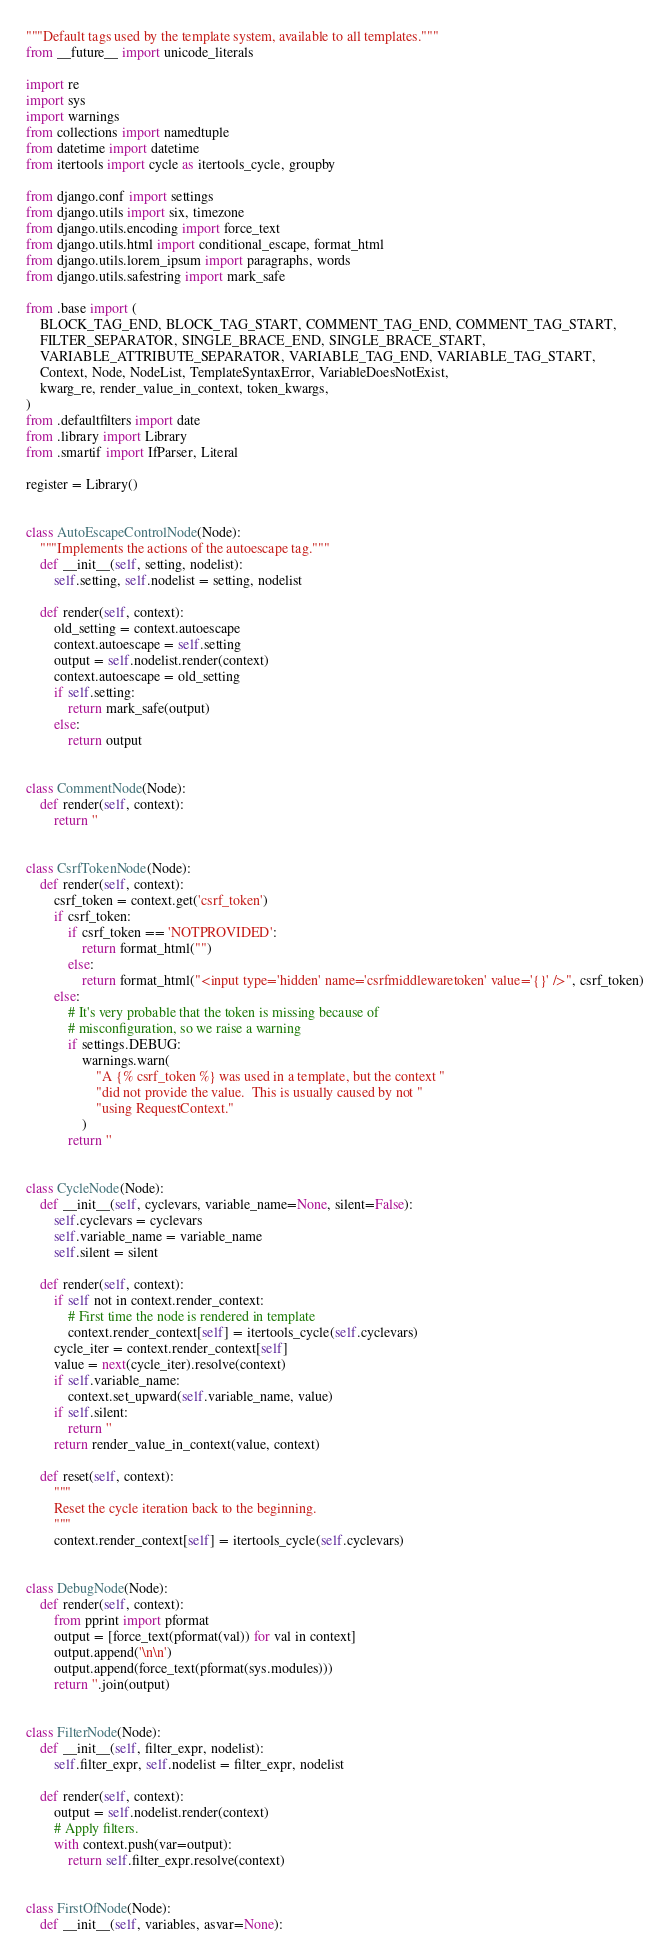Convert code to text. <code><loc_0><loc_0><loc_500><loc_500><_Python_>"""Default tags used by the template system, available to all templates."""
from __future__ import unicode_literals

import re
import sys
import warnings
from collections import namedtuple
from datetime import datetime
from itertools import cycle as itertools_cycle, groupby

from django.conf import settings
from django.utils import six, timezone
from django.utils.encoding import force_text
from django.utils.html import conditional_escape, format_html
from django.utils.lorem_ipsum import paragraphs, words
from django.utils.safestring import mark_safe

from .base import (
    BLOCK_TAG_END, BLOCK_TAG_START, COMMENT_TAG_END, COMMENT_TAG_START,
    FILTER_SEPARATOR, SINGLE_BRACE_END, SINGLE_BRACE_START,
    VARIABLE_ATTRIBUTE_SEPARATOR, VARIABLE_TAG_END, VARIABLE_TAG_START,
    Context, Node, NodeList, TemplateSyntaxError, VariableDoesNotExist,
    kwarg_re, render_value_in_context, token_kwargs,
)
from .defaultfilters import date
from .library import Library
from .smartif import IfParser, Literal

register = Library()


class AutoEscapeControlNode(Node):
    """Implements the actions of the autoescape tag."""
    def __init__(self, setting, nodelist):
        self.setting, self.nodelist = setting, nodelist

    def render(self, context):
        old_setting = context.autoescape
        context.autoescape = self.setting
        output = self.nodelist.render(context)
        context.autoescape = old_setting
        if self.setting:
            return mark_safe(output)
        else:
            return output


class CommentNode(Node):
    def render(self, context):
        return ''


class CsrfTokenNode(Node):
    def render(self, context):
        csrf_token = context.get('csrf_token')
        if csrf_token:
            if csrf_token == 'NOTPROVIDED':
                return format_html("")
            else:
                return format_html("<input type='hidden' name='csrfmiddlewaretoken' value='{}' />", csrf_token)
        else:
            # It's very probable that the token is missing because of
            # misconfiguration, so we raise a warning
            if settings.DEBUG:
                warnings.warn(
                    "A {% csrf_token %} was used in a template, but the context "
                    "did not provide the value.  This is usually caused by not "
                    "using RequestContext."
                )
            return ''


class CycleNode(Node):
    def __init__(self, cyclevars, variable_name=None, silent=False):
        self.cyclevars = cyclevars
        self.variable_name = variable_name
        self.silent = silent

    def render(self, context):
        if self not in context.render_context:
            # First time the node is rendered in template
            context.render_context[self] = itertools_cycle(self.cyclevars)
        cycle_iter = context.render_context[self]
        value = next(cycle_iter).resolve(context)
        if self.variable_name:
            context.set_upward(self.variable_name, value)
        if self.silent:
            return ''
        return render_value_in_context(value, context)

    def reset(self, context):
        """
        Reset the cycle iteration back to the beginning.
        """
        context.render_context[self] = itertools_cycle(self.cyclevars)


class DebugNode(Node):
    def render(self, context):
        from pprint import pformat
        output = [force_text(pformat(val)) for val in context]
        output.append('\n\n')
        output.append(force_text(pformat(sys.modules)))
        return ''.join(output)


class FilterNode(Node):
    def __init__(self, filter_expr, nodelist):
        self.filter_expr, self.nodelist = filter_expr, nodelist

    def render(self, context):
        output = self.nodelist.render(context)
        # Apply filters.
        with context.push(var=output):
            return self.filter_expr.resolve(context)


class FirstOfNode(Node):
    def __init__(self, variables, asvar=None):</code> 